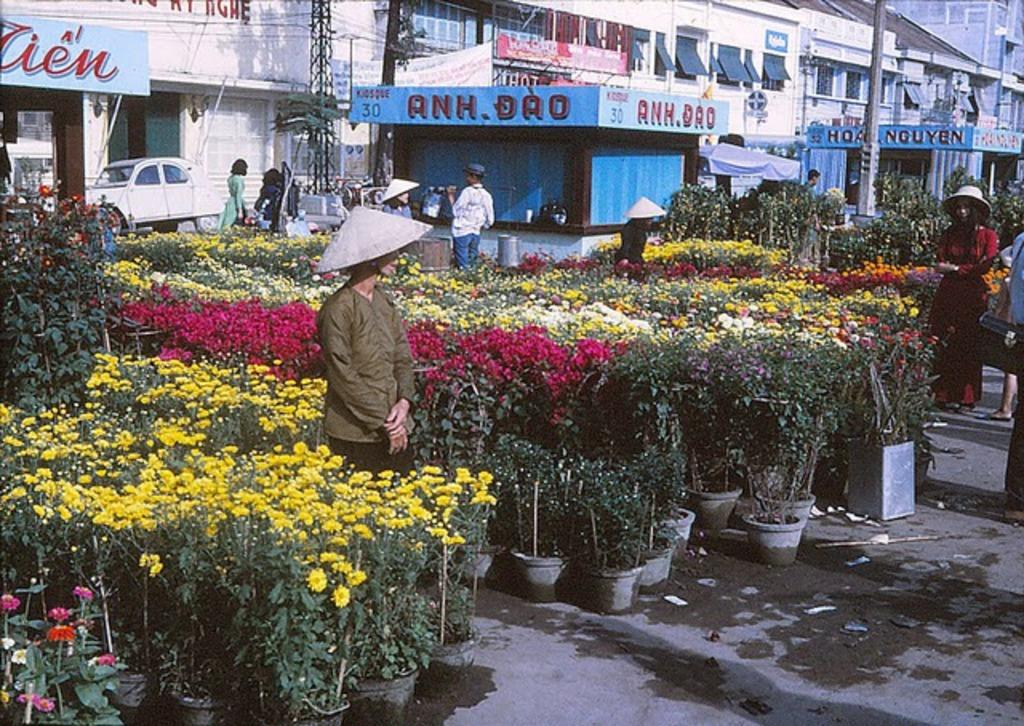What type of structure is visible in the image? There is a building in the image. What is located in front of the building? There is a vehicle and people in front of the building. What type of establishments are present in front of the building? There are stores in front of the building. What is displayed on the walls of the stores? There are hoardings in front of the stores. What type of vegetation can be seen in front of the stores? There are plants with flowers in front of the stores. Who is present near the plants with flowers? There are people beside the plants with flowers. What type of vessel is being used for scientific experiments in the image? There is no vessel or scientific experiment present in the image. How many hands are visible in the image? The image does not show any hands; it primarily features a building, people, and plants. 